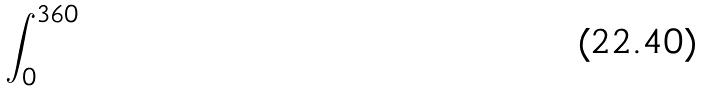<formula> <loc_0><loc_0><loc_500><loc_500>\int _ { 0 } ^ { 3 6 0 }</formula> 